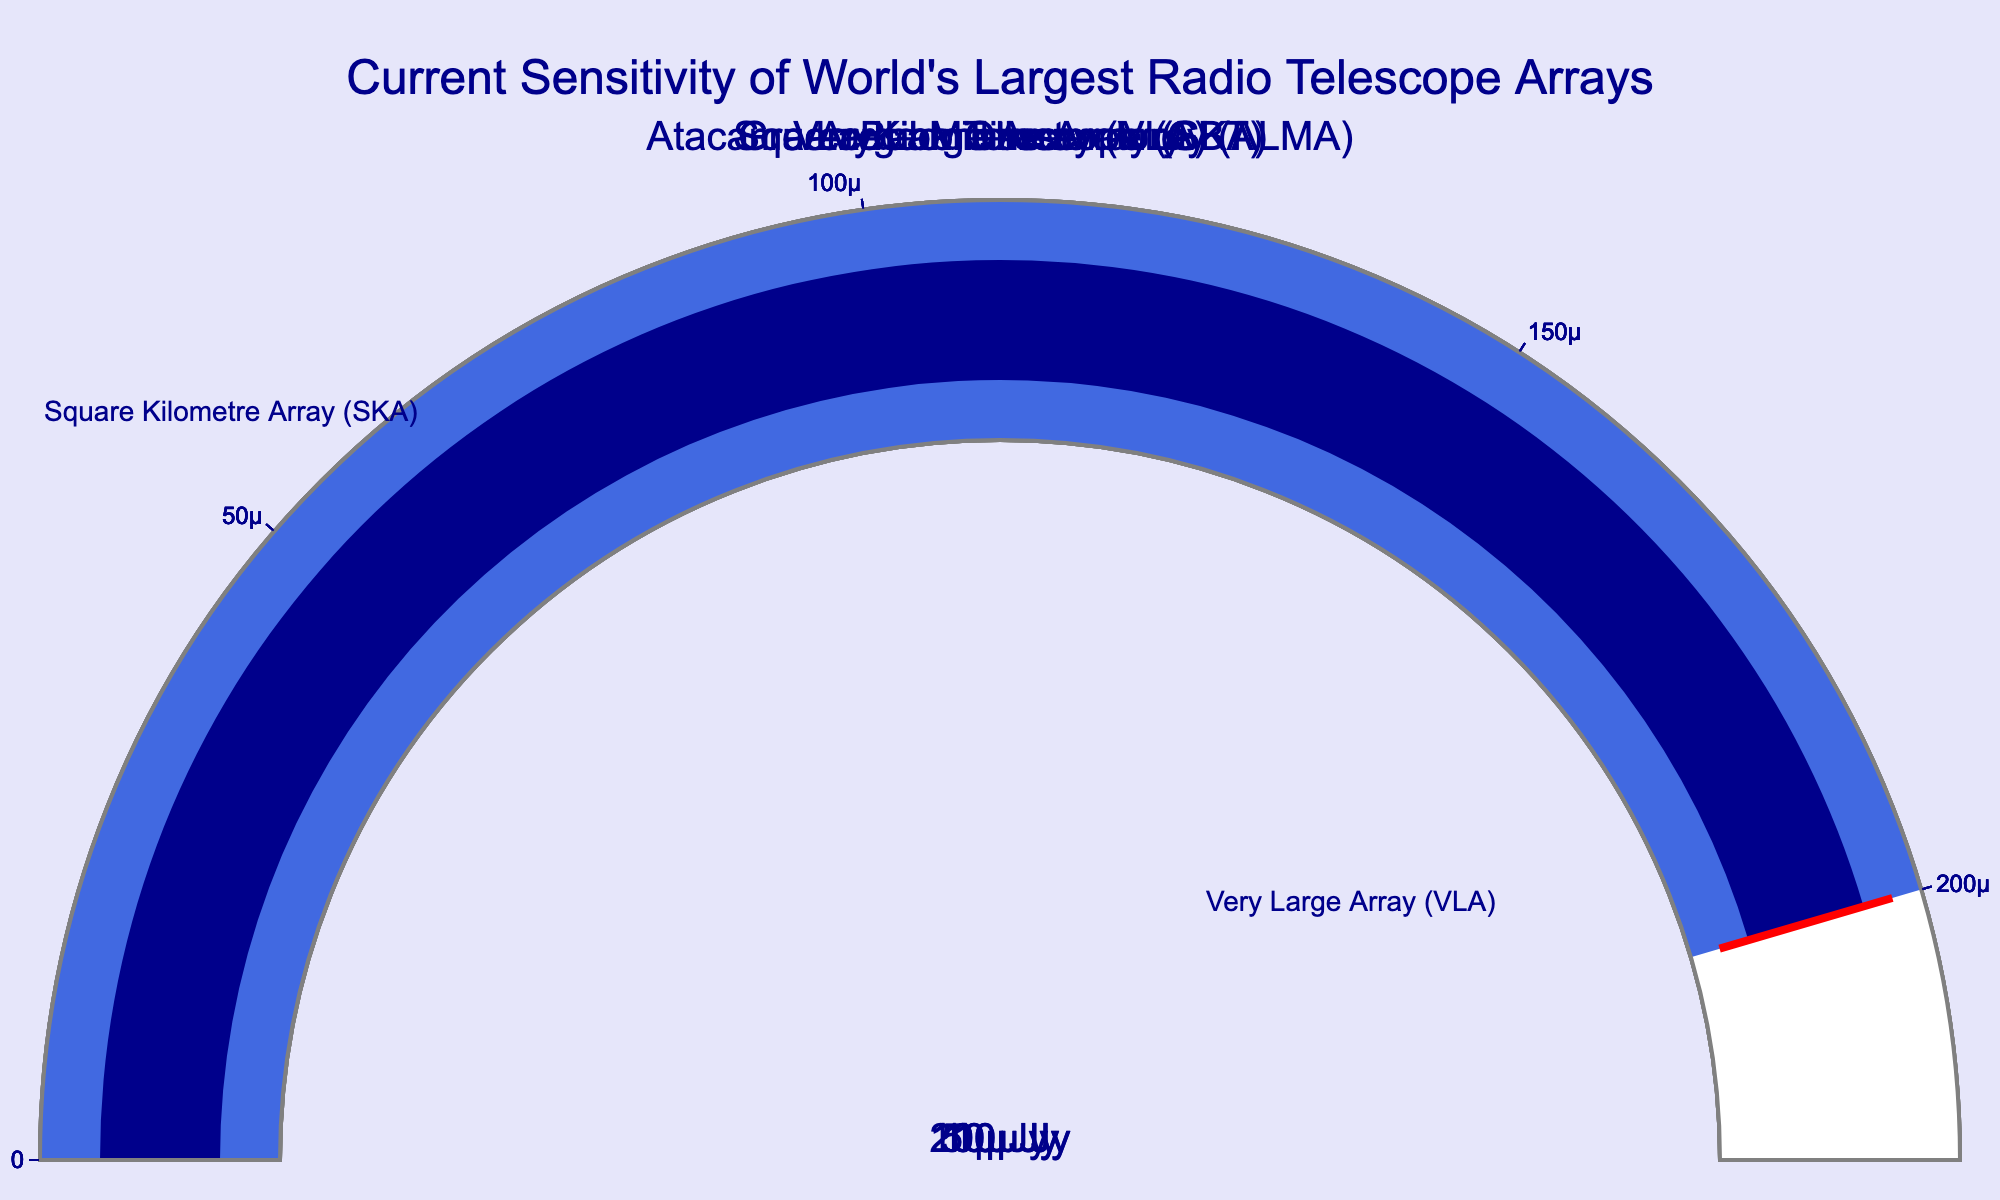What's the title of the figure? The title of the figure is displayed prominently at the top and reads "Current Sensitivity of World's Largest Radio Telescope Arrays". This is written in a large, dark blue font for emphasis.
Answer: Current Sensitivity of World's Largest Radio Telescope Arrays Which telescope has the highest sensitivity according to the figure? The gauge chart displays values for each telescope, represented visually. Comparing the values, the Square Kilometre Array (SKA) has the lowest sensitivity value indicating it is the most sensitive.
Answer: Square Kilometre Array (SKA) Which telescope has the least sensitivity? By examining the gauges, we see that the Green Bank Telescope (GBT) has the highest value, which means it is the least sensitive among the listed telescopes.
Answer: Green Bank Telescope (GBT) What is the sensitivity value of the Very Large Array (VLA)? The sensitivity value of each telescope is displayed directly in the center of each gauge. The gauge for the Very Large Array (VLA) shows a sensitivity of 0.00001 Jy.
Answer: 0.00001 Jy Can you rank the telescopes from the highest to the lowest sensitivity? To rank the telescopes, observe the gauge values in ascending order. The higher the value, the less sensitive the telescope. The ranking from highest to lowest sensitivity is: Square Kilometre Array (SKA), Very Large Array (VLA), Atacama Large Millimeter Array (ALMA), Arecibo Observatory, Green Bank Telescope (GBT).
Answer: SKA, VLA, ALMA, Arecibo, GBT What is the combined sensitivity value of the SKA and ALMA? To find the combined sensitivity, sum the values of the SKA (0.000001 Jy) and ALMA (0.00005 Jy). 0.000001 + 0.00005 = 0.000051 Jy.
Answer: 0.000051 Jy Which telescope's sensitivity is twice that of the ALMA? The sensitivity of ALMA is 0.00005 Jy. We need to find if any telescope's sensitivity is approximately double this value. The sensitivity of the Arecibo Observatory (0.0001 Jy) is exactly twice 0.00005 Jy.
Answer: Arecibo Observatory What is the difference in sensitivity between the SKA and GBT? Subtract the sensitivity value of SKA (0.000001 Jy) from the GBT (0.0002 Jy) to get the difference. 0.0002 - 0.000001 = 0.000199 Jy.
Answer: 0.000199 Jy What would be the estimated average sensitivity of all these telescopes? Add all the sensitivities together and divide by the number of telescopes: (0.000001 + 0.00001 + 0.00005 + 0.0001 + 0.0002) / 5. Calculate the sum first: 0.000001 + 0.00001 + 0.00005 + 0.0001 + 0.0002 = 0.000361. Then, divide by 5: 0.000361 / 5 = 0.0000722 Jy.
Answer: 0.0000722 Jy How much more sensitive is the VLA compared to the GBT? To determine the difference in sensitivity, subtract the VLA's sensitivity (0.00001 Jy) from the GBT's (0.0002 Jy). 0.0002 Jy - 0.00001 Jy = 0.00019 Jy.
Answer: 0.00019 Jy 